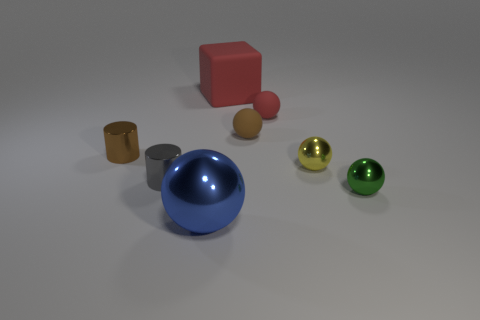What objects in the image appear to be made of metal? In the image, two cylindrical objects—one of larger size and one smaller—have a metallic sheen to them, indicating that they might be made of metal. 